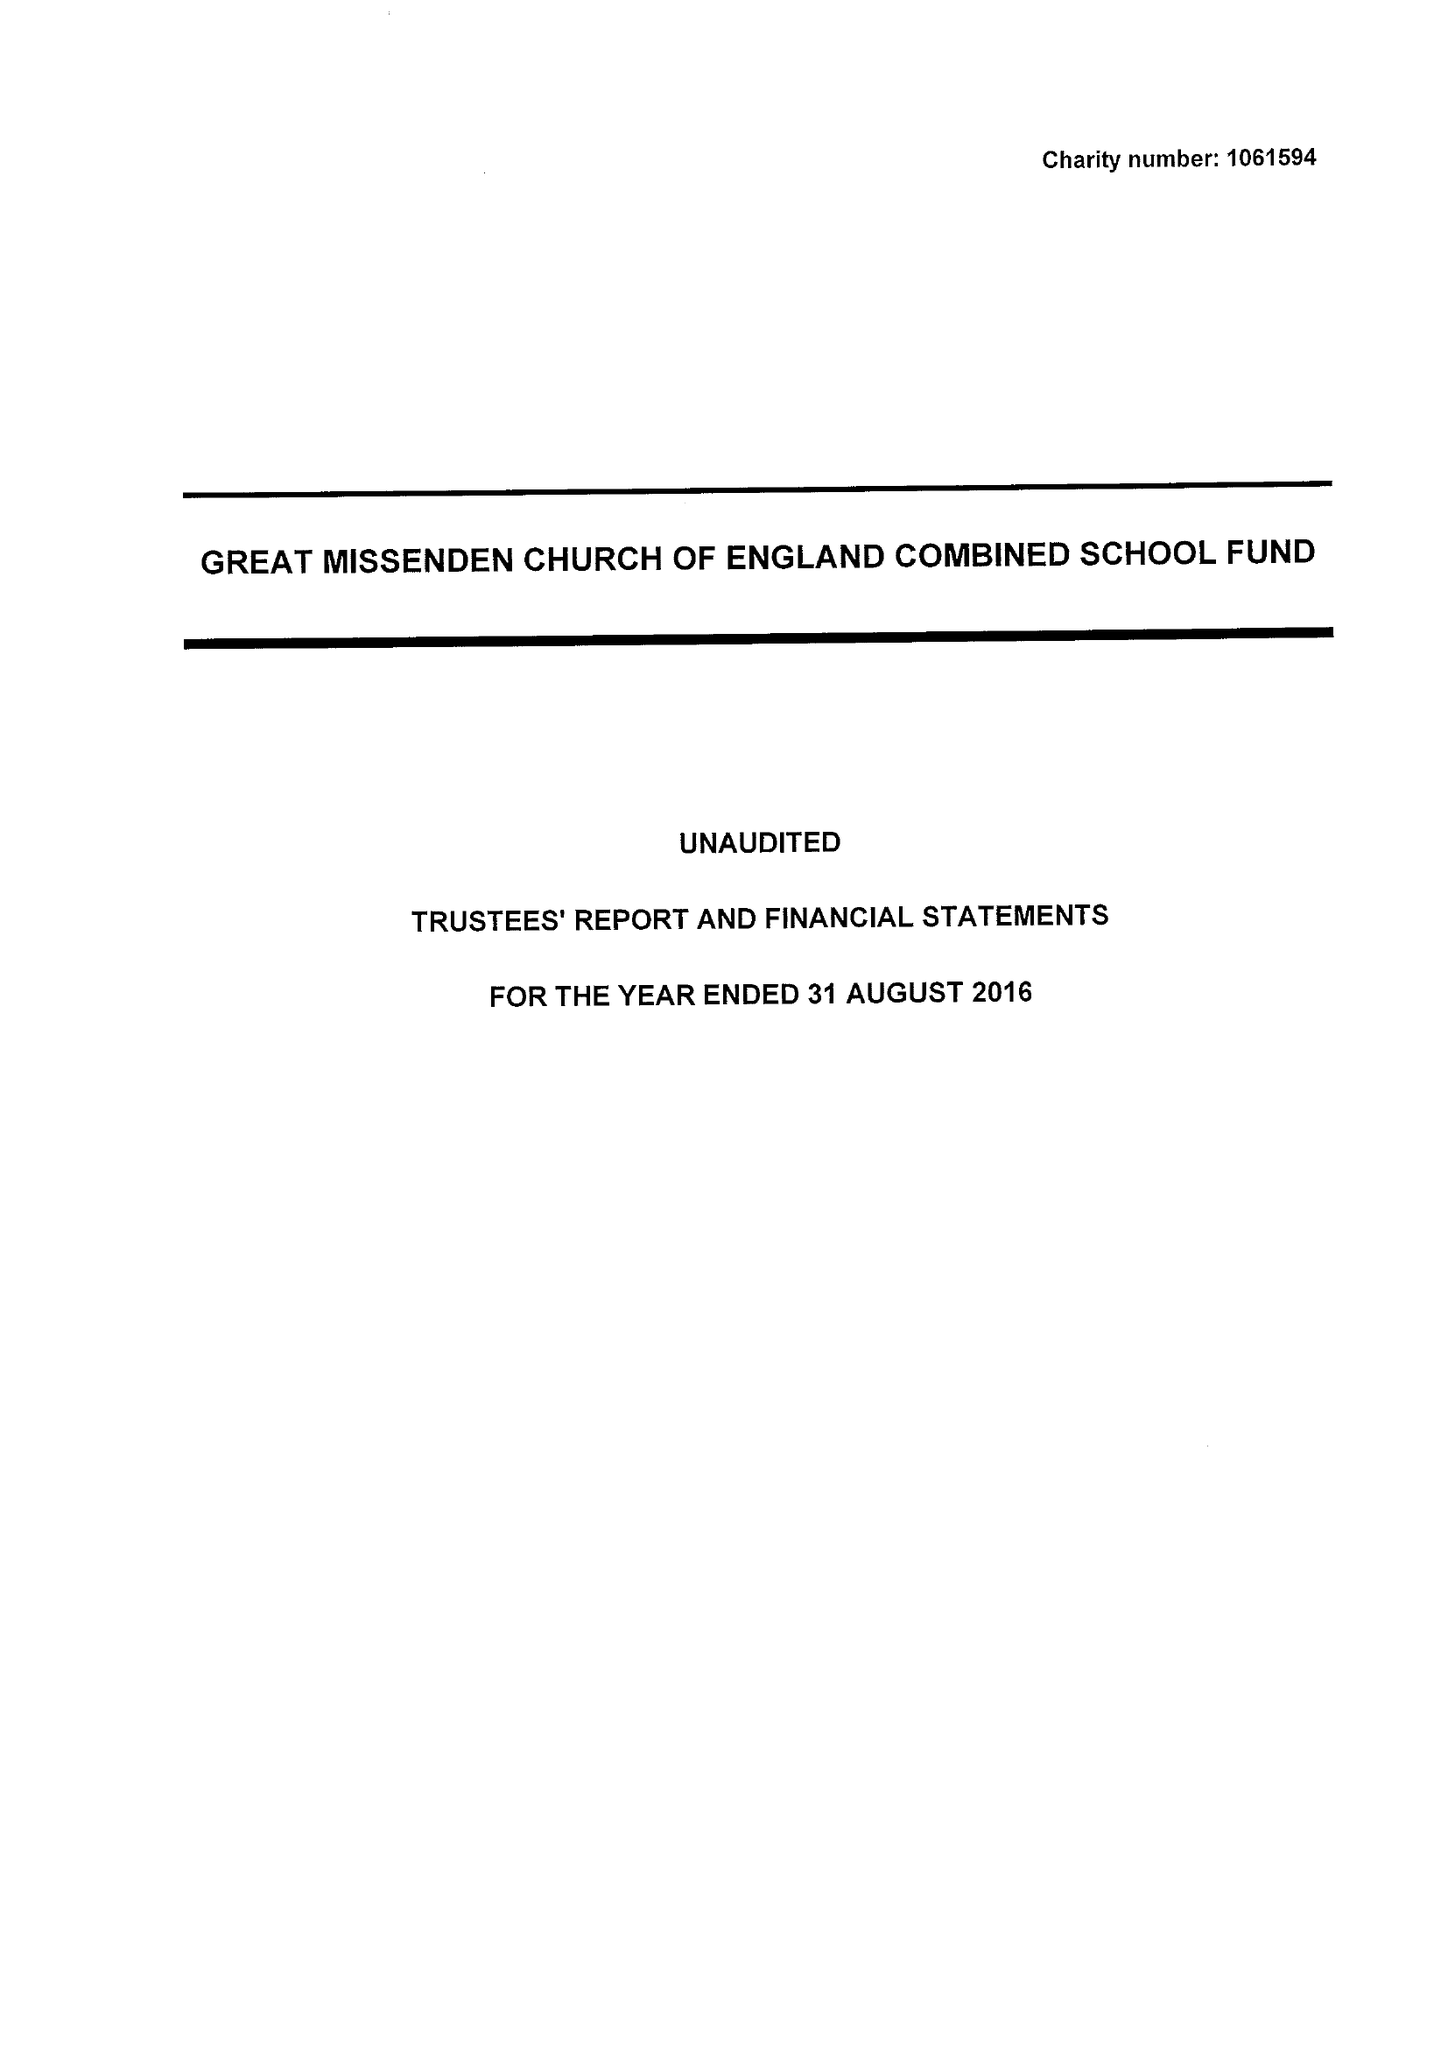What is the value for the charity_number?
Answer the question using a single word or phrase. 1061594 